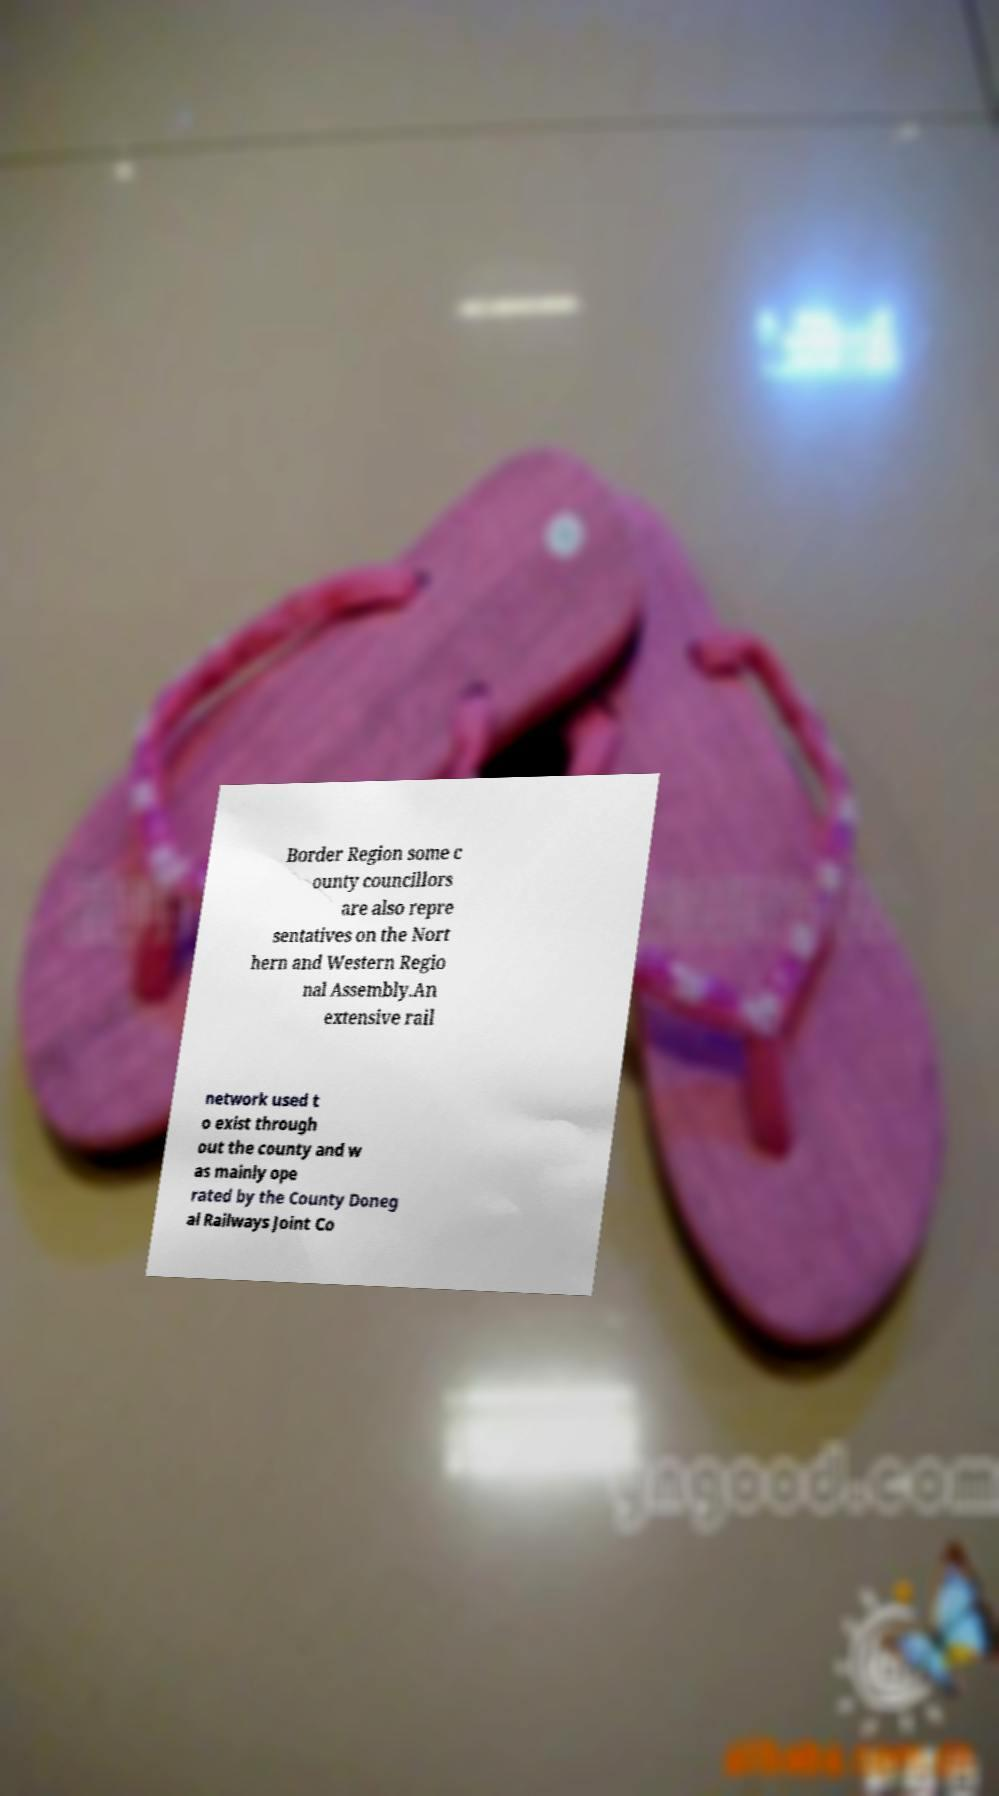Could you extract and type out the text from this image? Border Region some c ounty councillors are also repre sentatives on the Nort hern and Western Regio nal Assembly.An extensive rail network used t o exist through out the county and w as mainly ope rated by the County Doneg al Railways Joint Co 